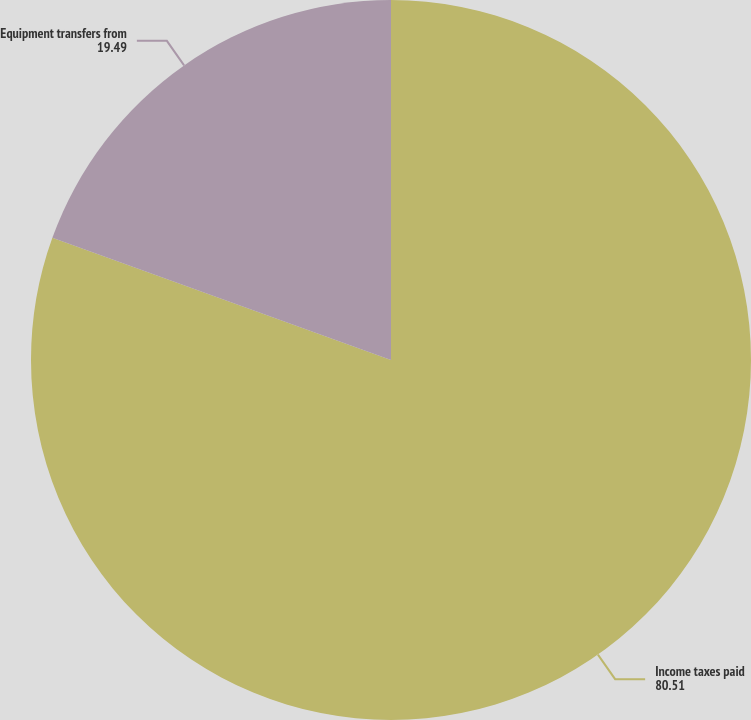Convert chart to OTSL. <chart><loc_0><loc_0><loc_500><loc_500><pie_chart><fcel>Income taxes paid<fcel>Equipment transfers from<nl><fcel>80.51%<fcel>19.49%<nl></chart> 